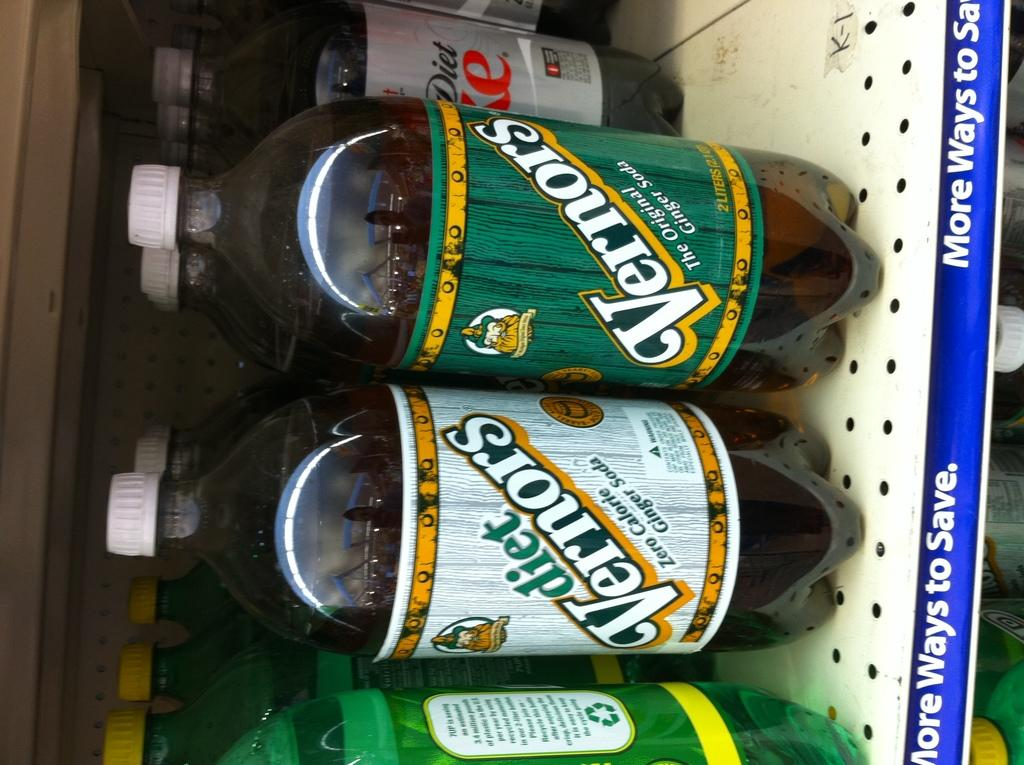Provide a one-sentence caption for the provided image. A shelf has bottles for Vernors and diet Vernors ginger soda. 